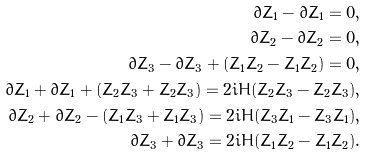<formula> <loc_0><loc_0><loc_500><loc_500>\partial \bar { Z } _ { 1 } - \bar { \partial } Z _ { 1 } = 0 , \\ \partial \bar { Z } _ { 2 } - \bar { \partial } Z _ { 2 } = 0 , \\ \partial \bar { Z } _ { 3 } - \bar { \partial } Z _ { 3 } + ( Z _ { 1 } \bar { Z } _ { 2 } - \bar { Z } _ { 1 } Z _ { 2 } ) = 0 , \\ \partial \bar { Z } _ { 1 } + \bar { \partial } Z _ { 1 } + ( Z _ { 2 } \bar { Z } _ { 3 } + \bar { Z } _ { 2 } Z _ { 3 } ) = 2 i H ( \bar { Z } _ { 2 } Z _ { 3 } - Z _ { 2 } \bar { Z } _ { 3 } ) , \\ \partial \bar { Z } _ { 2 } + \bar { \partial } Z _ { 2 } - ( Z _ { 1 } \bar { Z } _ { 3 } + \bar { Z } _ { 1 } Z _ { 3 } ) = 2 i H ( \bar { Z } _ { 3 } Z _ { 1 } - Z _ { 3 } \bar { Z } _ { 1 } ) , \\ \partial \bar { Z } _ { 3 } + \bar { \partial } Z _ { 3 } = 2 i H ( \bar { Z } _ { 1 } Z _ { 2 } - Z _ { 1 } \bar { Z } _ { 2 } ) .</formula> 